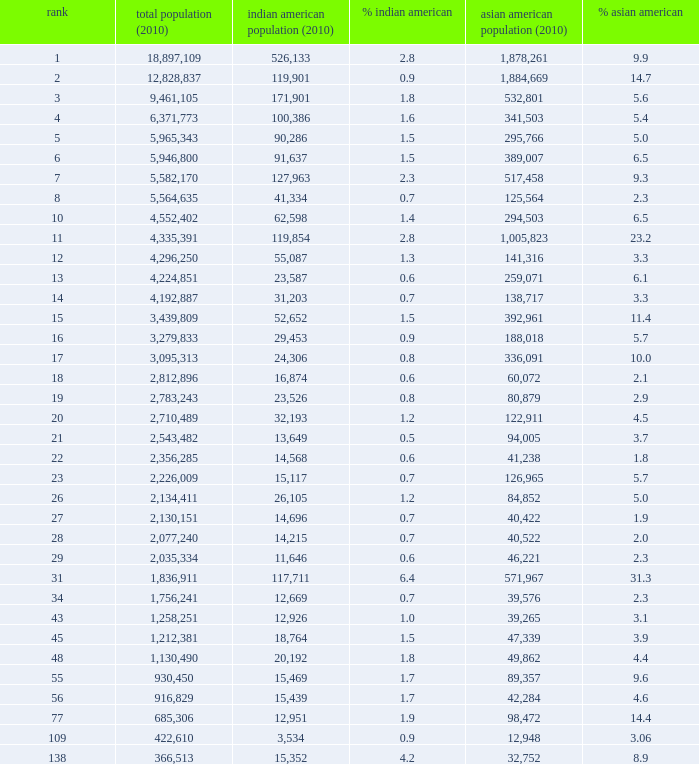What's the total population when the Asian American population is less than 60,072, the Indian American population is more than 14,696 and is 4.2% Indian American? 366513.0. 